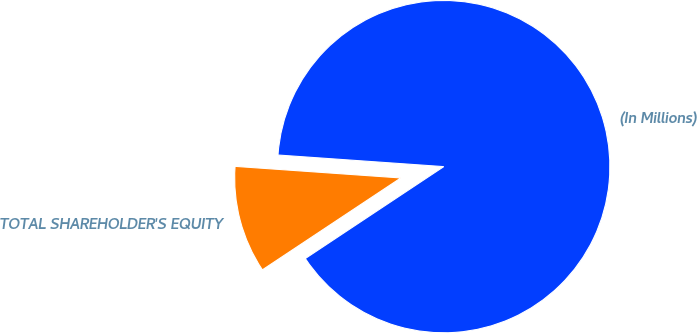Convert chart. <chart><loc_0><loc_0><loc_500><loc_500><pie_chart><fcel>(In Millions)<fcel>TOTAL SHAREHOLDER'S EQUITY<nl><fcel>89.56%<fcel>10.44%<nl></chart> 